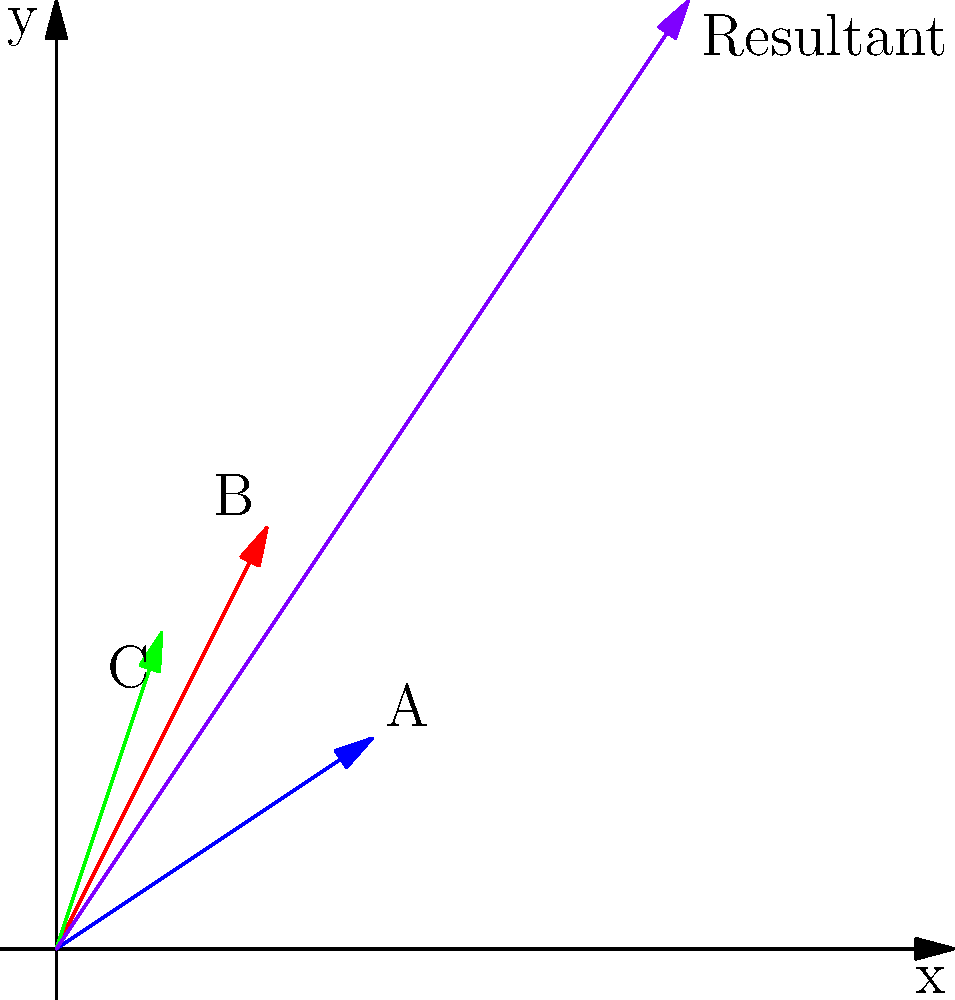As an economic development specialist, you're advising three small businesses (A, B, and C) on resource allocation. Each business's current resource allocation is represented by a vector in the graph above. Business A's vector is $(3,2)$, B's is $(2,4)$, and C's is $(1,3)$. If you want to optimize the overall resource allocation for all three businesses combined, what would be the coordinates of the resultant vector? To optimize the overall resource allocation for all three businesses, we need to add their individual resource vectors together. This process is known as vector addition.

Step 1: Identify the vectors
Business A: $\vec{a} = (3,2)$
Business B: $\vec{b} = (2,4)$
Business C: $\vec{c} = (1,3)$

Step 2: Add the x-components
$x_{resultant} = 3 + 2 + 1 = 6$

Step 3: Add the y-components
$y_{resultant} = 2 + 4 + 3 = 9$

Step 4: Express the resultant vector
The resultant vector $\vec{r} = (x_{resultant}, y_{resultant}) = (6,9)$

This resultant vector represents the optimized overall resource allocation for all three businesses combined. It suggests where the collective efforts and resources should be focused to maximize the impact of the economic development initiatives.
Answer: $(6,9)$ 